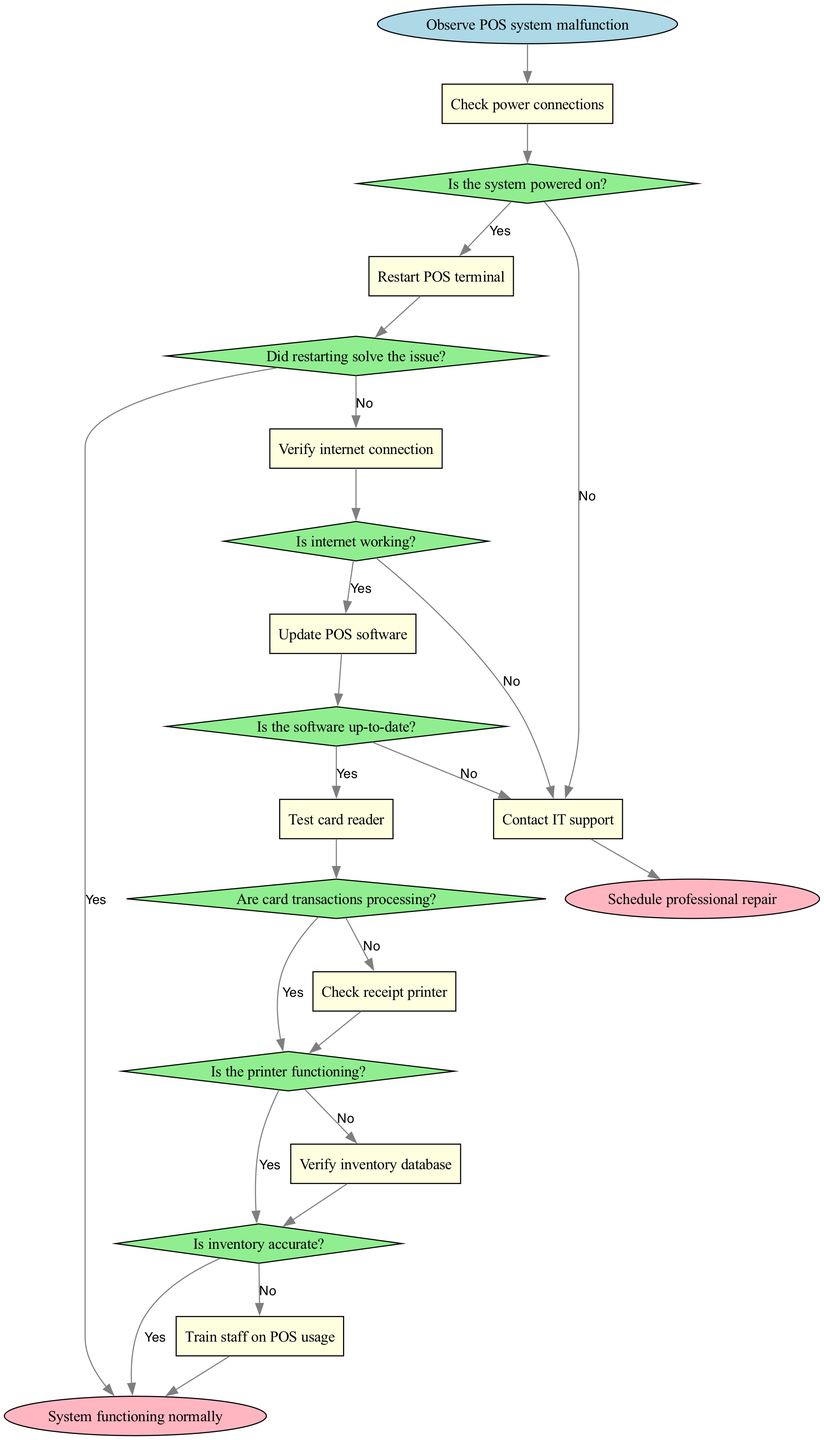What is the first activity to check in the troubleshooting process? The first activity in the diagram is directly connected to the start node, which is "Check power connections."
Answer: Check power connections How many activities are listed in the diagram? By counting the activities presented in the diagram, there are eight activities in total: "Check power connections," "Restart POS terminal," "Verify internet connection," "Update POS software," "Contact IT support," "Test card reader," "Check receipt printer," and "Verify inventory database."
Answer: 8 What happens if the system is not powered on? If the system is not powered on, the activity following the decision "Is the system powered on?" is "Restart POS terminal," leading to further troubleshooting steps.
Answer: Restart POS terminal What is the outcome if the printer is functioning? If the printer is functioning according to the decision "Is the printer functioning?" then the flow leads to the end node "System functioning normally."
Answer: System functioning normally What is the last decision before contacting IT support? The last decision before contacting IT support is "Is the software up-to-date?" If the software is not updated, it leads to the "Contact IT support" activity.
Answer: Is the software up-to-date? How many end nodes are presented in the diagram? The diagram contains two end nodes, which are "System functioning normally" and "Schedule professional repair."
Answer: 2 What occurs after verifying the inventory database? After reaching the activity "Verify inventory database," the next decision is "Is inventory accurate?" Based on that decision, it either leads to another activity or the conclusion.
Answer: Is inventory accurate? If the card transactions are not processing, what will be the next step? If card transactions are not processing according to the decision "Are card transactions processing?" the flow leads to the activity "Contact IT support" for further assistance.
Answer: Contact IT support 